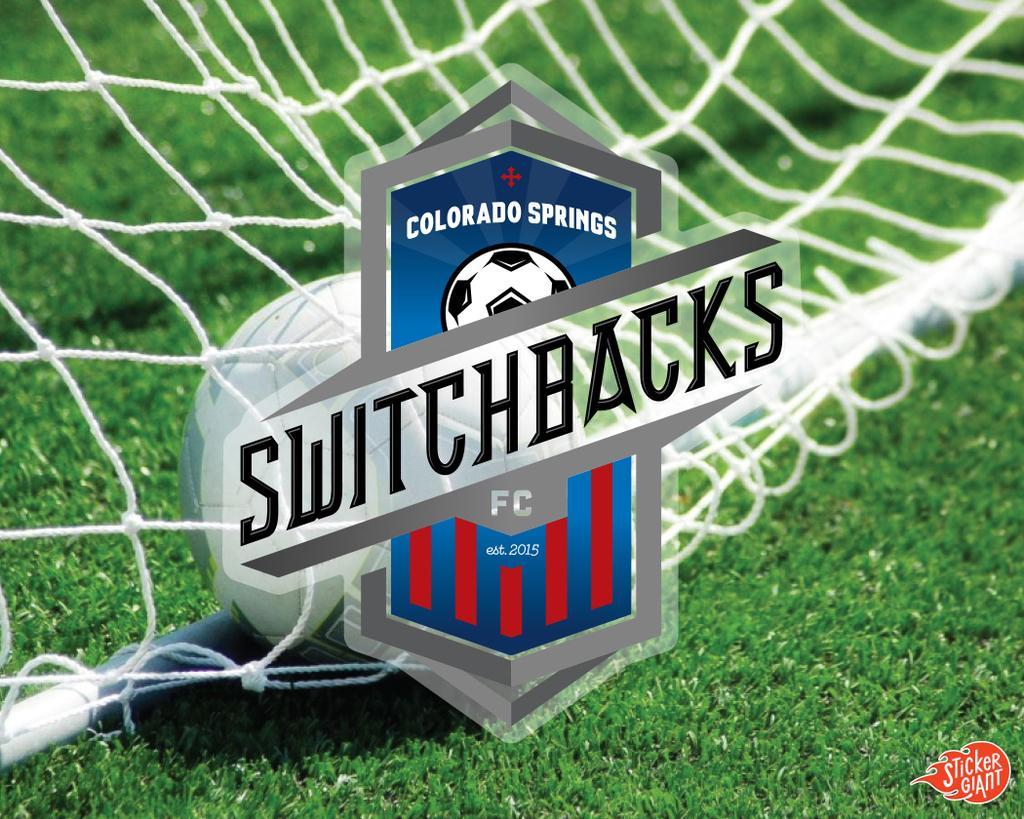Describe this image in one or two sentences. In this image there is a ball on the ground. In front of it there are ropes. There is the grass on the ground. In the center there are text and a logo. In the bottom right there is text on the image. 